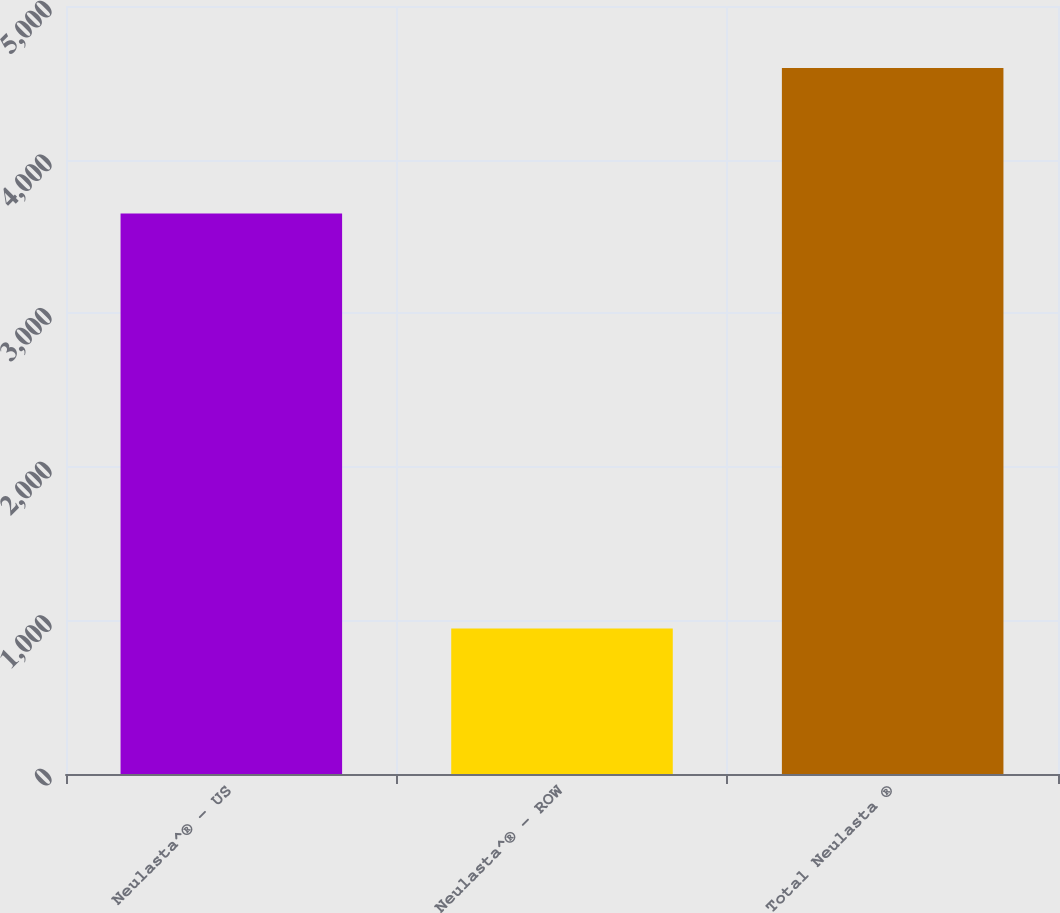<chart> <loc_0><loc_0><loc_500><loc_500><bar_chart><fcel>Neulasta^® - US<fcel>Neulasta^® - ROW<fcel>Total Neulasta ®<nl><fcel>3649<fcel>947<fcel>4596<nl></chart> 